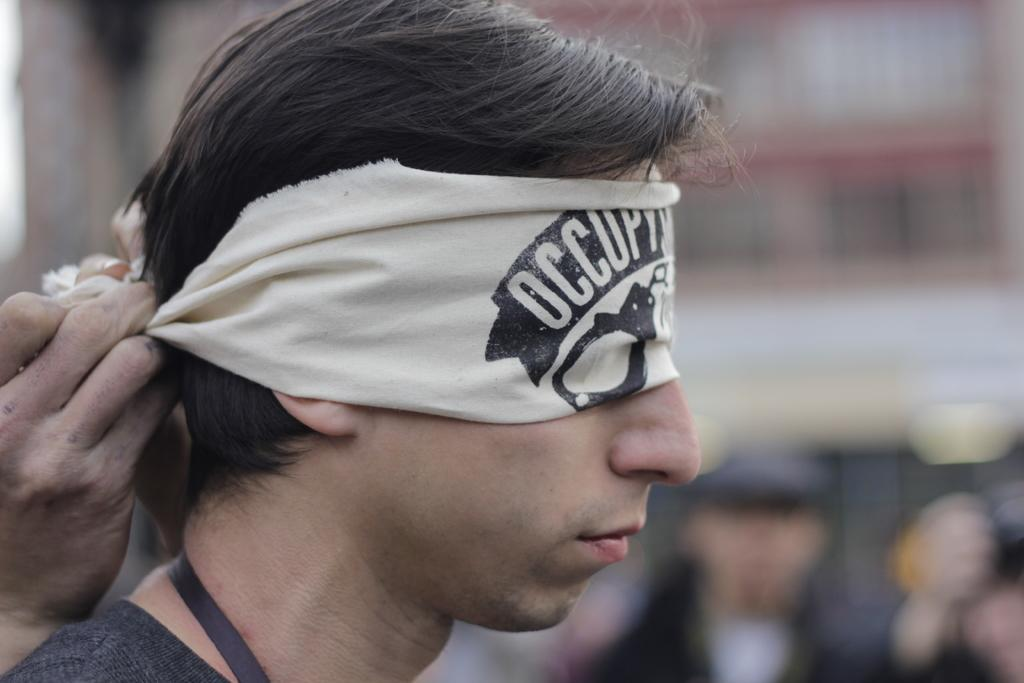What is the main subject of the image? There is a person in the center of the image with closed eyes and a blindfold. What can be seen on the left side of the image? There is a person's hand on the left side of the image. How would you describe the background of the image? The background of the image is blurry. What color is the shirt worn by the cherry in the image? There is no cherry present in the image, and therefore no shirt worn by a cherry can be observed. 